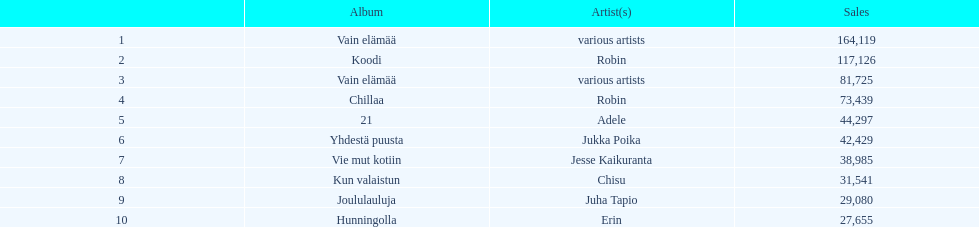Which album, lacking an assigned artist, has achieved the highest sales figures? Vain elämää. 